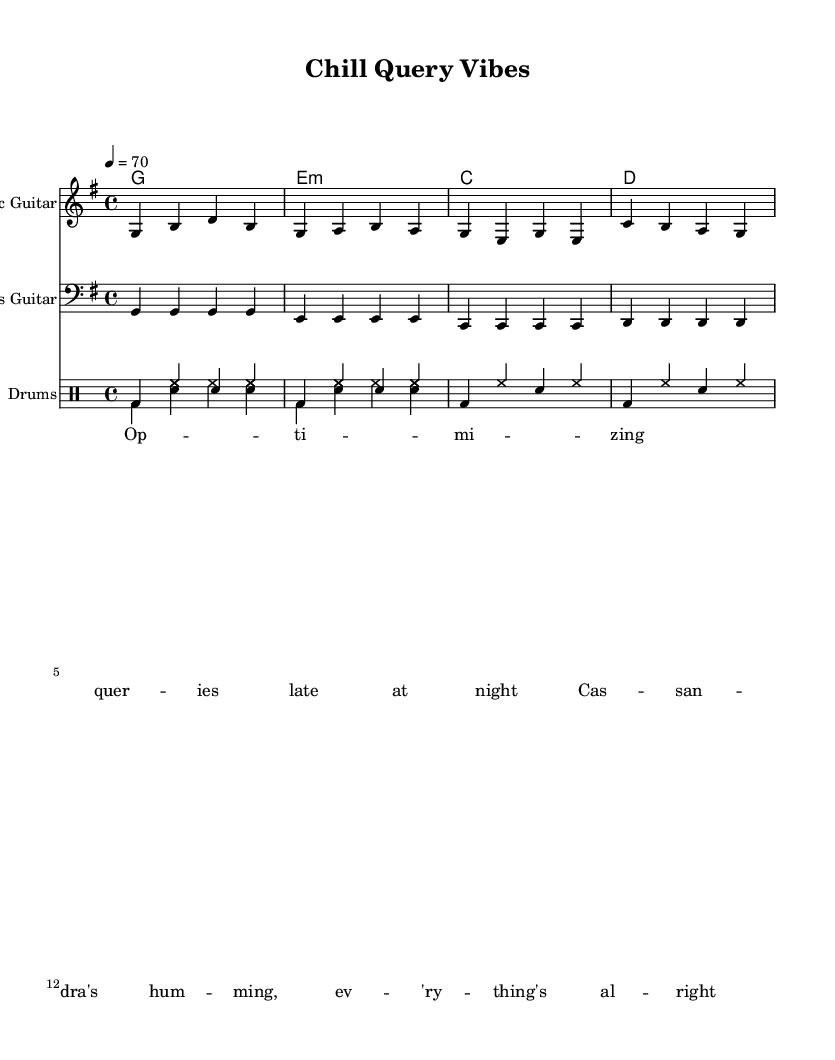What is the key signature of this music? The key signature is G major, which has one sharp (F#). You can identify the key signature by looking at the beginning of the staff where the sharp is indicated.
Answer: G major What is the time signature of this music? The time signature is 4/4, indicated at the beginning of the sheet music after the key signature. This means there are four beats in each measure and the quarter note gets one beat.
Answer: 4/4 What is the tempo marking for this piece? The tempo marking is 4 equals 70, which indicates that the quarter note (4) should be played at a speed of 70 beats per minute. This is usually found in the header section of the music.
Answer: 70 How many measures are in the electric guitar part? There are four measures in the electric guitar part. To determine this, you can count the vertical lines (bar lines) that separate the music into measures; there are four sections before the repeat.
Answer: 4 What chords are being used in this piece? The chords used are G, E minor, C, and D. This information is found in the ChordNames section; each chord is noted in the chord mode aligned with the music.
Answer: G, E minor, C, D What is the general mood conveyed by the emphasized lyrics in this reggae piece? The lyrics emphasize feelings of relaxation and positivity, as indicated by phrases like "everything's all right." This reflects the laid-back, easygoing vibe commonly associated with reggae music.
Answer: Relaxation How many drum voices are present in the drum part? There are two drum voices present in the drum part, as indicated by the two separate entries labeled as DrumVoice in the staff section.
Answer: 2 